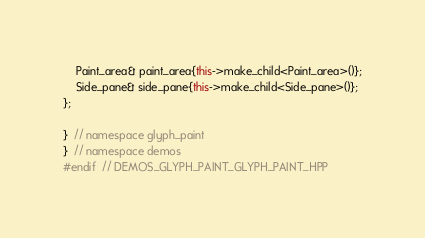<code> <loc_0><loc_0><loc_500><loc_500><_C++_>    Paint_area& paint_area{this->make_child<Paint_area>()};
    Side_pane& side_pane{this->make_child<Side_pane>()};
};

}  // namespace glyph_paint
}  // namespace demos
#endif  // DEMOS_GLYPH_PAINT_GLYPH_PAINT_HPP
</code> 